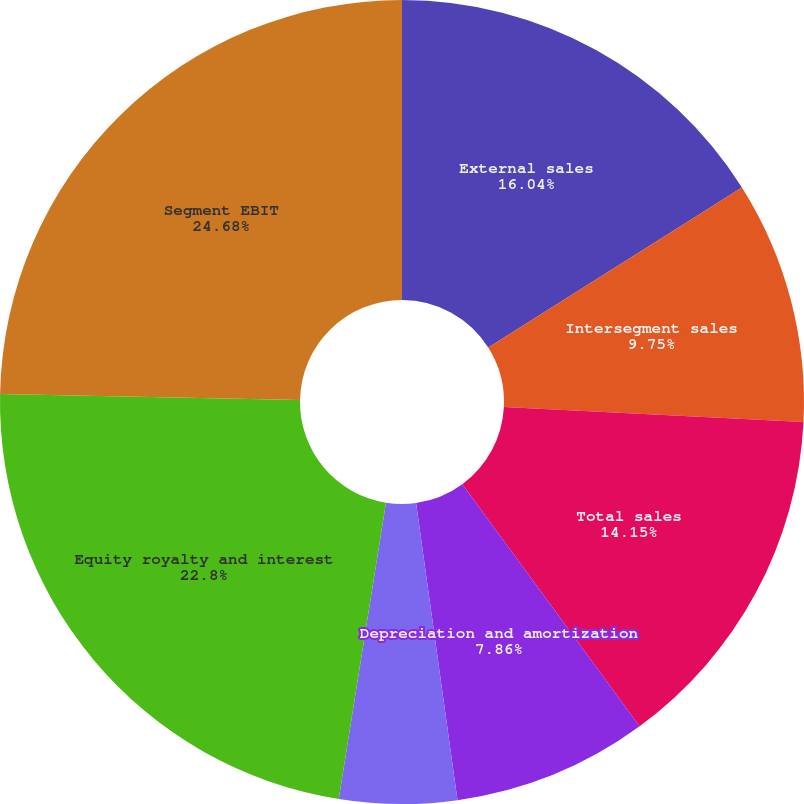<chart> <loc_0><loc_0><loc_500><loc_500><pie_chart><fcel>External sales<fcel>Intersegment sales<fcel>Total sales<fcel>Depreciation and amortization<fcel>Research development and<fcel>Equity royalty and interest<fcel>Segment EBIT<nl><fcel>16.04%<fcel>9.75%<fcel>14.15%<fcel>7.86%<fcel>4.72%<fcel>22.8%<fcel>24.69%<nl></chart> 